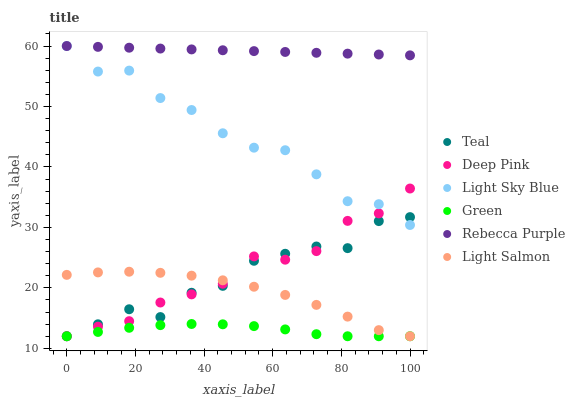Does Green have the minimum area under the curve?
Answer yes or no. Yes. Does Rebecca Purple have the maximum area under the curve?
Answer yes or no. Yes. Does Deep Pink have the minimum area under the curve?
Answer yes or no. No. Does Deep Pink have the maximum area under the curve?
Answer yes or no. No. Is Rebecca Purple the smoothest?
Answer yes or no. Yes. Is Teal the roughest?
Answer yes or no. Yes. Is Deep Pink the smoothest?
Answer yes or no. No. Is Deep Pink the roughest?
Answer yes or no. No. Does Light Salmon have the lowest value?
Answer yes or no. Yes. Does Light Sky Blue have the lowest value?
Answer yes or no. No. Does Rebecca Purple have the highest value?
Answer yes or no. Yes. Does Deep Pink have the highest value?
Answer yes or no. No. Is Light Salmon less than Light Sky Blue?
Answer yes or no. Yes. Is Light Sky Blue greater than Light Salmon?
Answer yes or no. Yes. Does Teal intersect Deep Pink?
Answer yes or no. Yes. Is Teal less than Deep Pink?
Answer yes or no. No. Is Teal greater than Deep Pink?
Answer yes or no. No. Does Light Salmon intersect Light Sky Blue?
Answer yes or no. No. 